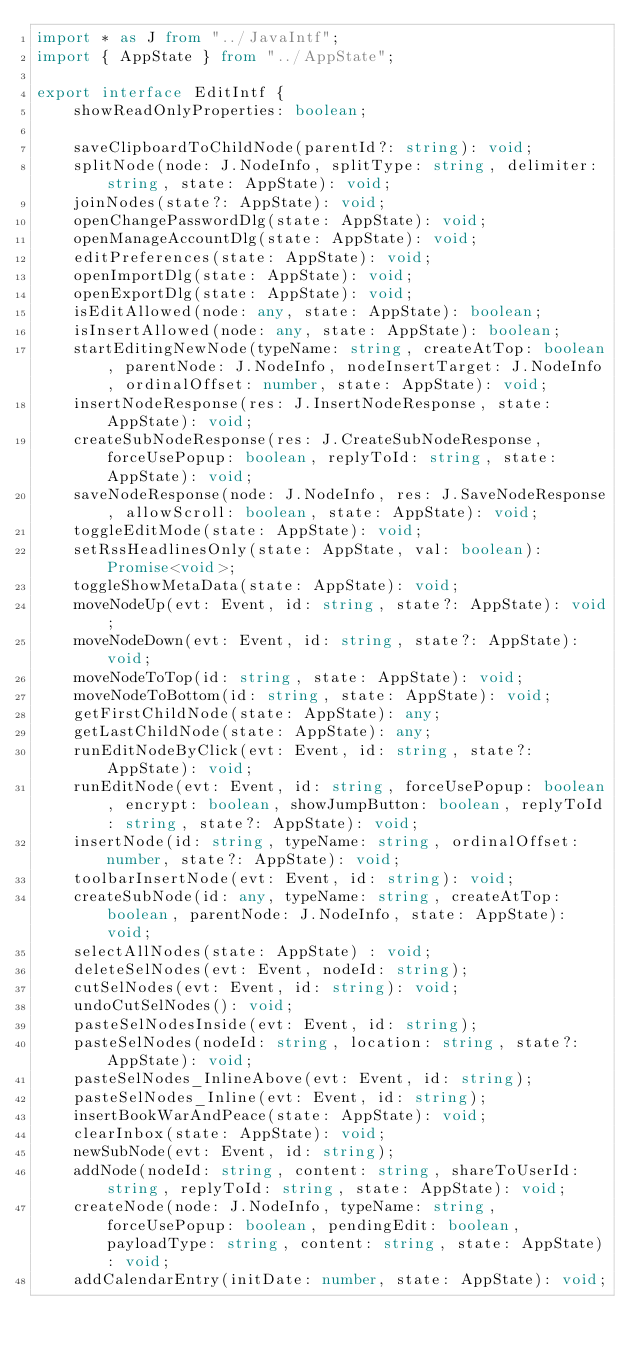Convert code to text. <code><loc_0><loc_0><loc_500><loc_500><_TypeScript_>import * as J from "../JavaIntf";
import { AppState } from "../AppState";

export interface EditIntf {
    showReadOnlyProperties: boolean;

    saveClipboardToChildNode(parentId?: string): void;
    splitNode(node: J.NodeInfo, splitType: string, delimiter: string, state: AppState): void;
    joinNodes(state?: AppState): void;
    openChangePasswordDlg(state: AppState): void;
    openManageAccountDlg(state: AppState): void;
    editPreferences(state: AppState): void;
    openImportDlg(state: AppState): void;
    openExportDlg(state: AppState): void;
    isEditAllowed(node: any, state: AppState): boolean;
    isInsertAllowed(node: any, state: AppState): boolean;
    startEditingNewNode(typeName: string, createAtTop: boolean, parentNode: J.NodeInfo, nodeInsertTarget: J.NodeInfo, ordinalOffset: number, state: AppState): void;
    insertNodeResponse(res: J.InsertNodeResponse, state: AppState): void;
    createSubNodeResponse(res: J.CreateSubNodeResponse, forceUsePopup: boolean, replyToId: string, state: AppState): void;
    saveNodeResponse(node: J.NodeInfo, res: J.SaveNodeResponse, allowScroll: boolean, state: AppState): void;
    toggleEditMode(state: AppState): void;
    setRssHeadlinesOnly(state: AppState, val: boolean): Promise<void>;
    toggleShowMetaData(state: AppState): void;
    moveNodeUp(evt: Event, id: string, state?: AppState): void;
    moveNodeDown(evt: Event, id: string, state?: AppState): void;
    moveNodeToTop(id: string, state: AppState): void;
    moveNodeToBottom(id: string, state: AppState): void;
    getFirstChildNode(state: AppState): any;
    getLastChildNode(state: AppState): any;
    runEditNodeByClick(evt: Event, id: string, state?: AppState): void;
    runEditNode(evt: Event, id: string, forceUsePopup: boolean, encrypt: boolean, showJumpButton: boolean, replyToId: string, state?: AppState): void;
    insertNode(id: string, typeName: string, ordinalOffset: number, state?: AppState): void;
    toolbarInsertNode(evt: Event, id: string): void;
    createSubNode(id: any, typeName: string, createAtTop: boolean, parentNode: J.NodeInfo, state: AppState): void;
    selectAllNodes(state: AppState) : void;
    deleteSelNodes(evt: Event, nodeId: string);
    cutSelNodes(evt: Event, id: string): void;
    undoCutSelNodes(): void;
    pasteSelNodesInside(evt: Event, id: string);
    pasteSelNodes(nodeId: string, location: string, state?: AppState): void;
    pasteSelNodes_InlineAbove(evt: Event, id: string);
    pasteSelNodes_Inline(evt: Event, id: string);
    insertBookWarAndPeace(state: AppState): void;
    clearInbox(state: AppState): void;
    newSubNode(evt: Event, id: string);
    addNode(nodeId: string, content: string, shareToUserId: string, replyToId: string, state: AppState): void;
    createNode(node: J.NodeInfo, typeName: string, forceUsePopup: boolean, pendingEdit: boolean, payloadType: string, content: string, state: AppState): void;
    addCalendarEntry(initDate: number, state: AppState): void;</code> 